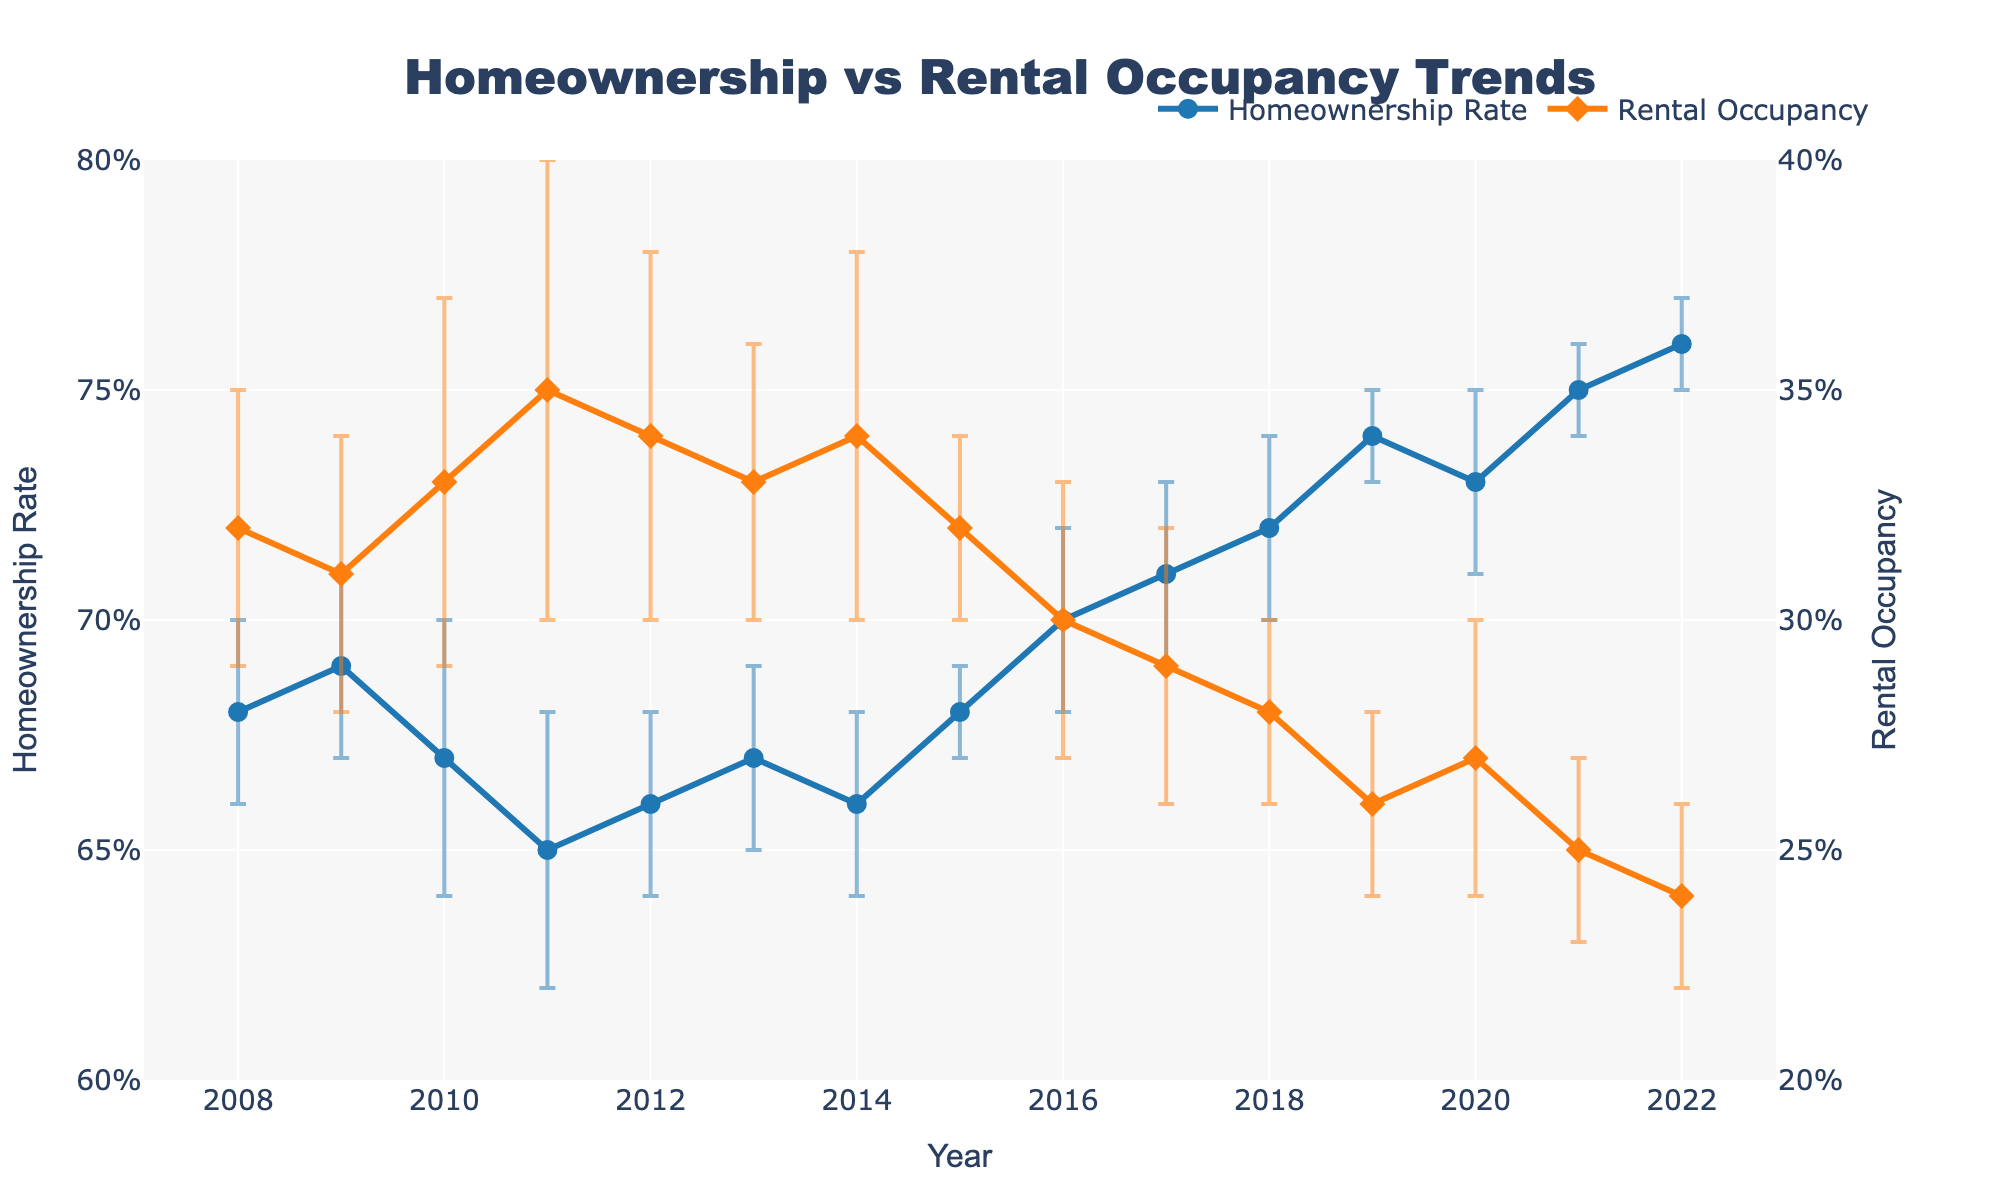What are the two y-axis titles in the figure? The figure has two y-axes, each with a different title. The left y-axis title is "Homeownership Rate," and the right y-axis title is "Rental Occupancy."
Answer: Homeownership Rate; Rental Occupancy In which year did the homeownership rate start to consistently increase after a period of decline? The homeownership rate declined until 2011 and then started to increase consistently from 2012 onward.
Answer: 2012 How many years of data are presented in the figure? The x-axis marks data from 2008 to 2022, which includes 15 years of data.
Answer: 15 What is the range of the homeownership rate displayed in the figure? The y-axis for the homeownership rate ranges from 0.6 to 0.8.
Answer: 0.6 to 0.8 Which year had the smallest rental occupancy rate, and what was the value? The smallest rental occupancy rate was in 2022 with a value of 0.24. This is indicated by the figure where the rental occupancy line reaches its lowest point in 2022.
Answer: 2022; 0.24 What is the difference in homeownership rate between 2008 and 2022? The homeownership rate in 2008 was 0.68 and in 2022 it was 0.76. So, the difference is 0.76 - 0.68.
Answer: 0.08 Compare the rental occupancy rates between 2011 and 2018. The rental occupancy rate in 2011 was 0.35 and in 2018 it was 0.28. Therefore, 0.35 is higher than 0.28.
Answer: 2011 is higher than 2018 What is the trend of homeownership and rental occupancy rates from 2015 to 2020? From 2015 to 2020, the homeownership rate shows an increasing trend while the rental occupancy rate displays a decreasing trend. This can be observed by analyzing the upward slope of the homeownership line and the downward slope of the rental occupancy line in this range of years.
Answer: Homeownership increases; Rental occupancy decreases Which year has the largest uncertainty in the rental occupancy, and what is the error value? The year 2011 has the largest uncertainty in the rental occupancy rate with an error value of 0.05. This is shown by the longest error bar for rental occupancy in the figure.
Answer: 2011; 0.05 